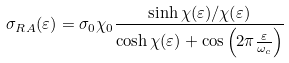<formula> <loc_0><loc_0><loc_500><loc_500>\sigma _ { R A } ( \varepsilon ) = \sigma _ { 0 } \chi _ { 0 } \frac { \sinh \chi ( \varepsilon ) / \chi ( \varepsilon ) } { \cosh \chi ( \varepsilon ) + \cos \left ( 2 \pi \frac { \varepsilon } { \omega _ { c } } \right ) }</formula> 